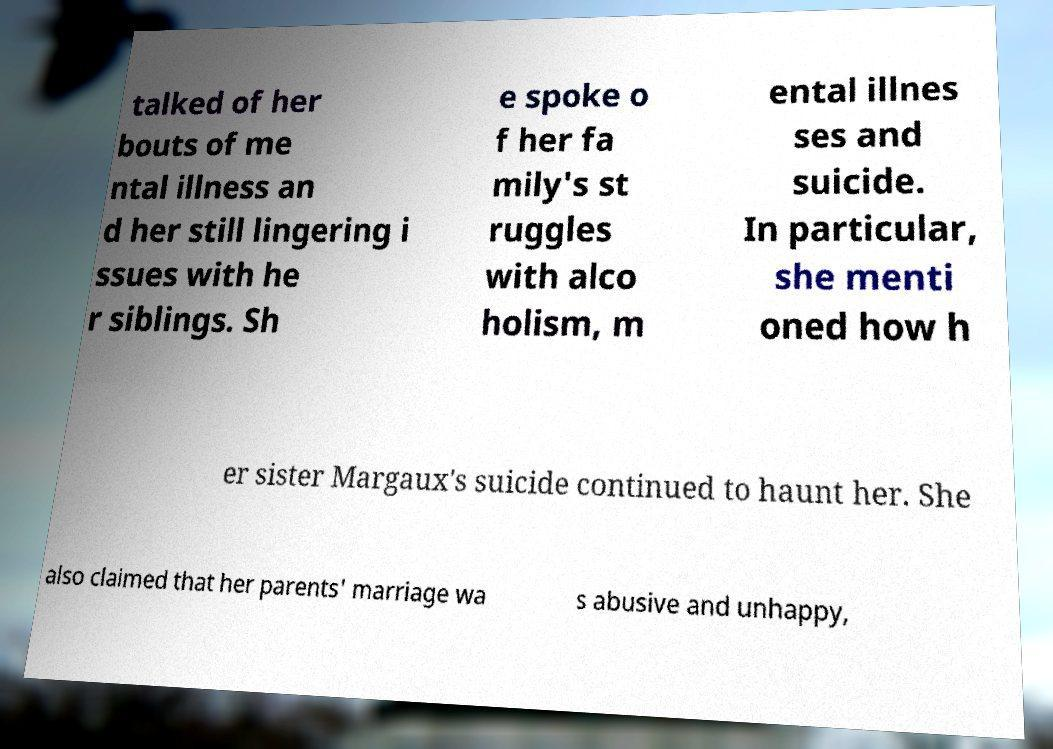Please read and relay the text visible in this image. What does it say? talked of her bouts of me ntal illness an d her still lingering i ssues with he r siblings. Sh e spoke o f her fa mily's st ruggles with alco holism, m ental illnes ses and suicide. In particular, she menti oned how h er sister Margaux's suicide continued to haunt her. She also claimed that her parents' marriage wa s abusive and unhappy, 